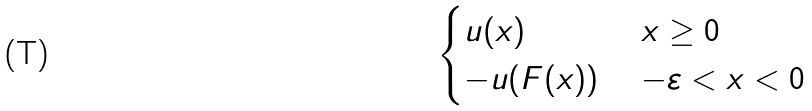Convert formula to latex. <formula><loc_0><loc_0><loc_500><loc_500>\begin{cases} u ( x ) \, & \, x \geq 0 \\ - u ( F ( x ) ) \, & \, - \varepsilon < x < 0 \\ \end{cases}</formula> 